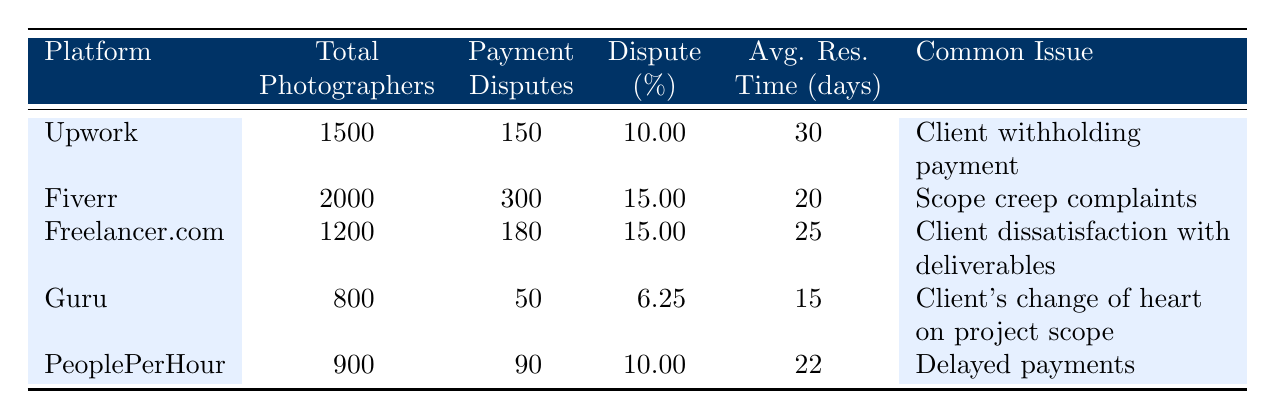What is the dispute percentage for Fiverr? The dispute percentage for Fiverr is listed directly in the table under the "Dispute (%)" column, which states 15.0.
Answer: 15.0 How many total photographers are on Guru? The total number of photographers using Guru is directly shown in the table under the "Total Photographers" column, which states 800.
Answer: 800 Which platform has the highest average resolution time for payment disputes? The average resolution time (in days) for each platform can be compared. Upwork has 30 days, Fiverr has 20 days, Freelancer.com has 25 days, Guru has 15 days, and PeoplePerHour has 22 days. Upwork has the highest at 30 days.
Answer: Upwork How many photographers faced payment disputes on Freelancer.com compared to Guru? Freelancer.com had 180 payment disputes while Guru had 50 payment disputes. To find the difference, subtract Guru's disputes from Freelancer.com's; 180 - 50 = 130.
Answer: 130 Is the common issue of delayed payments found on any platform other than PeoplePerHour? The common issue of delayed payments is unique to PeoplePerHour according to the table, as the other platforms list different issues.
Answer: No What is the average dispute percentage for all platforms combined? To calculate the average dispute percentage, add the percentages from each platform: 10.0 + 15.0 + 15.0 + 6.25 + 10.0 = 56.25. Then divide by the number of platforms (5): 56.25 / 5 = 11.25.
Answer: 11.25 Does Freelancer.com have a lower dispute percentage than Upwork? Freelancer.com's dispute percentage is 15.0, and Upwork's is 10.0. Since 15.0 is greater than 10.0, the statement is false.
Answer: No Which platform has the least number of payment disputes? By comparing the counts of payment disputes, Guru has the fewest with 50 compared to other platforms: Upwork (150), Fiverr (300), Freelancer.com (180), and PeoplePerHour (90).
Answer: Guru 